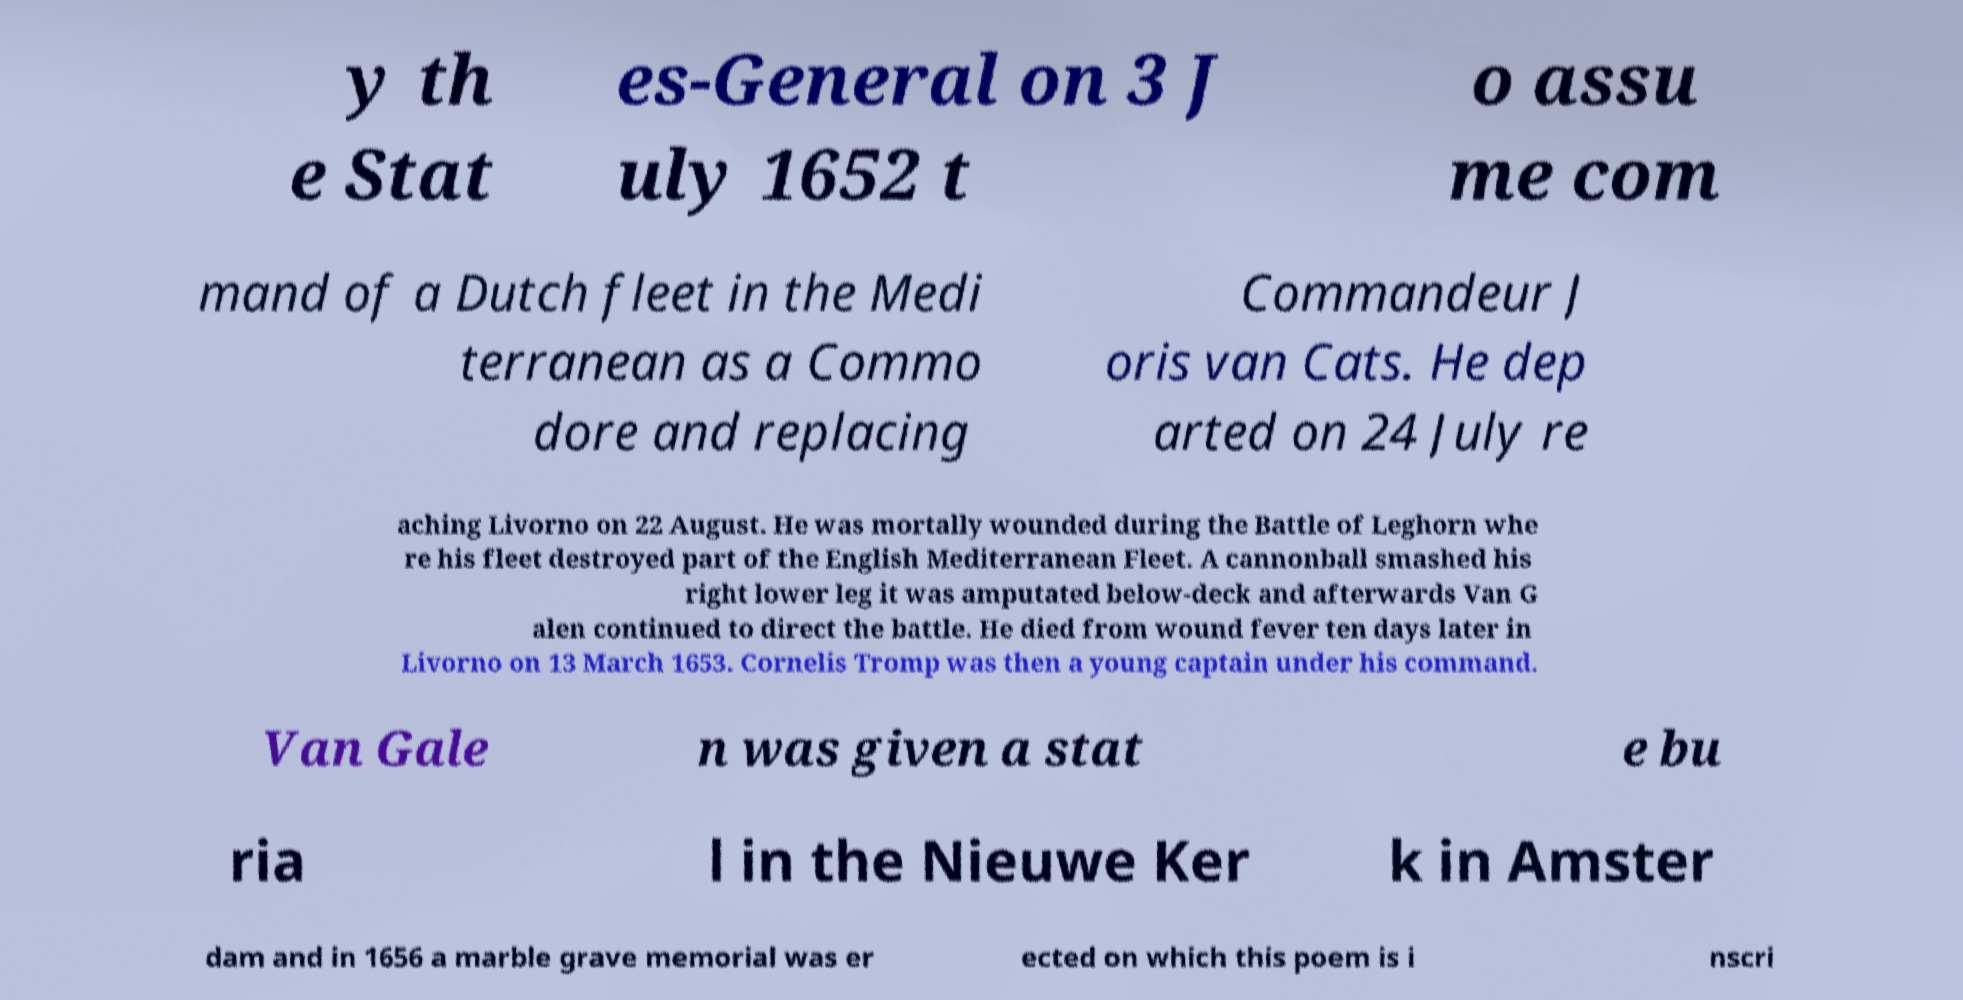Please identify and transcribe the text found in this image. y th e Stat es-General on 3 J uly 1652 t o assu me com mand of a Dutch fleet in the Medi terranean as a Commo dore and replacing Commandeur J oris van Cats. He dep arted on 24 July re aching Livorno on 22 August. He was mortally wounded during the Battle of Leghorn whe re his fleet destroyed part of the English Mediterranean Fleet. A cannonball smashed his right lower leg it was amputated below-deck and afterwards Van G alen continued to direct the battle. He died from wound fever ten days later in Livorno on 13 March 1653. Cornelis Tromp was then a young captain under his command. Van Gale n was given a stat e bu ria l in the Nieuwe Ker k in Amster dam and in 1656 a marble grave memorial was er ected on which this poem is i nscri 